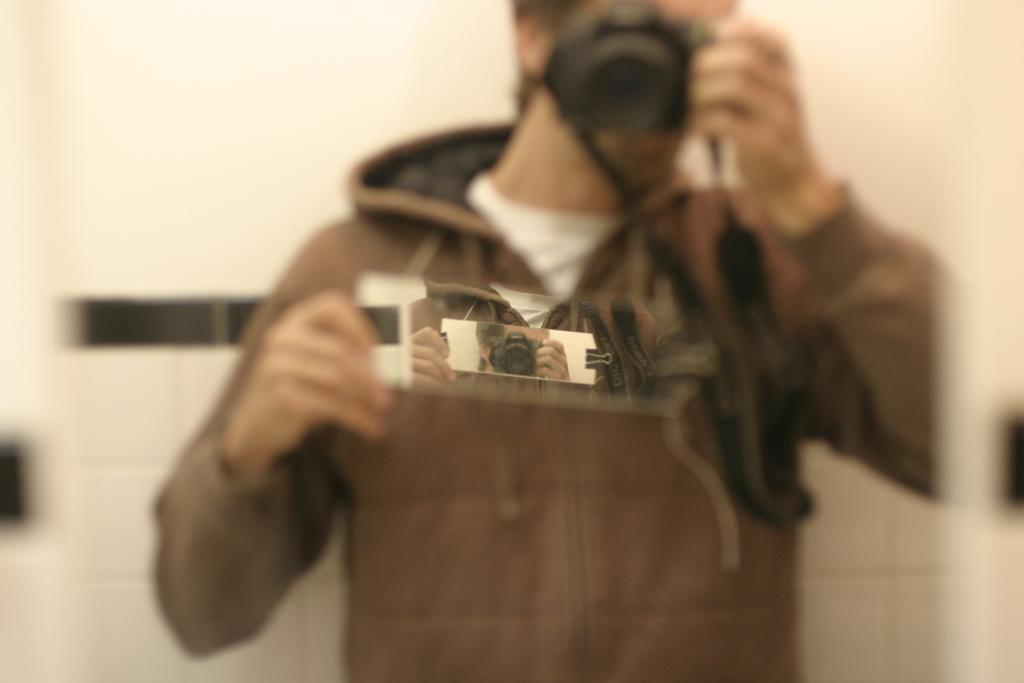Who is the main subject in the image? There is a man in the image. What is the man doing in the image? The man is standing in front of a mirror and taking a picture with a camera. What is the man wearing in the image? The man is wearing a brown-colored jacket. What type of cannon is visible in the image? There is no cannon present in the image. How many parts of the man's hair can be seen in the image? The image does not show the man's hair, so it is not possible to determine the number of parts. 